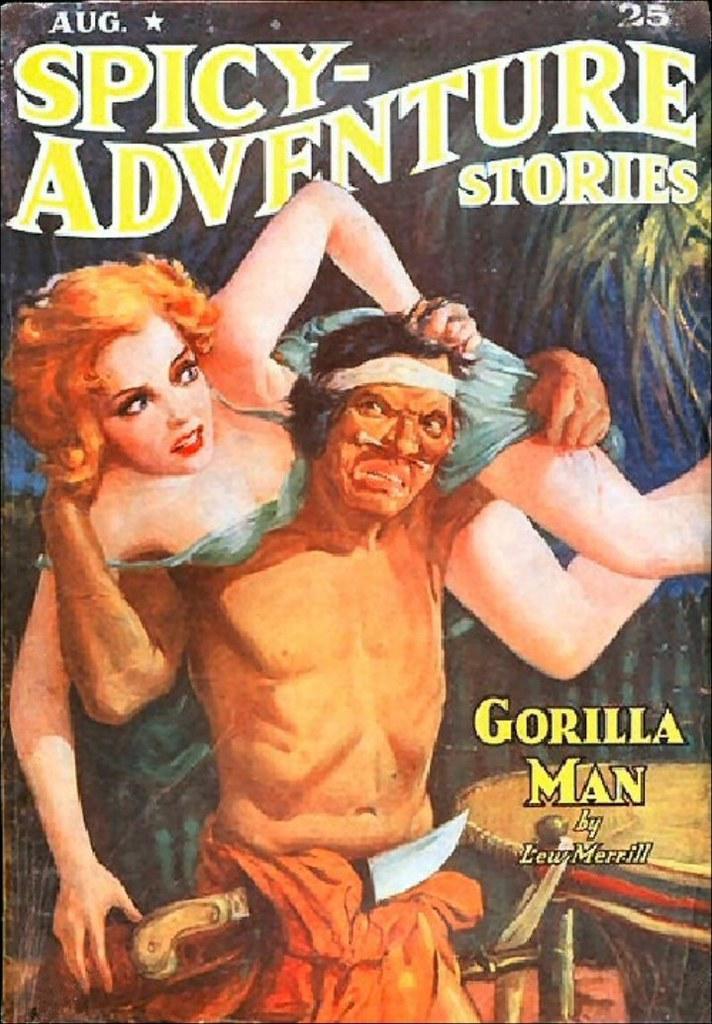Could you give a brief overview of what you see in this image? In this image I can see a poster and on it I can see depiction of people. On the top side and on the bottom right side of this image I can see something is written. 